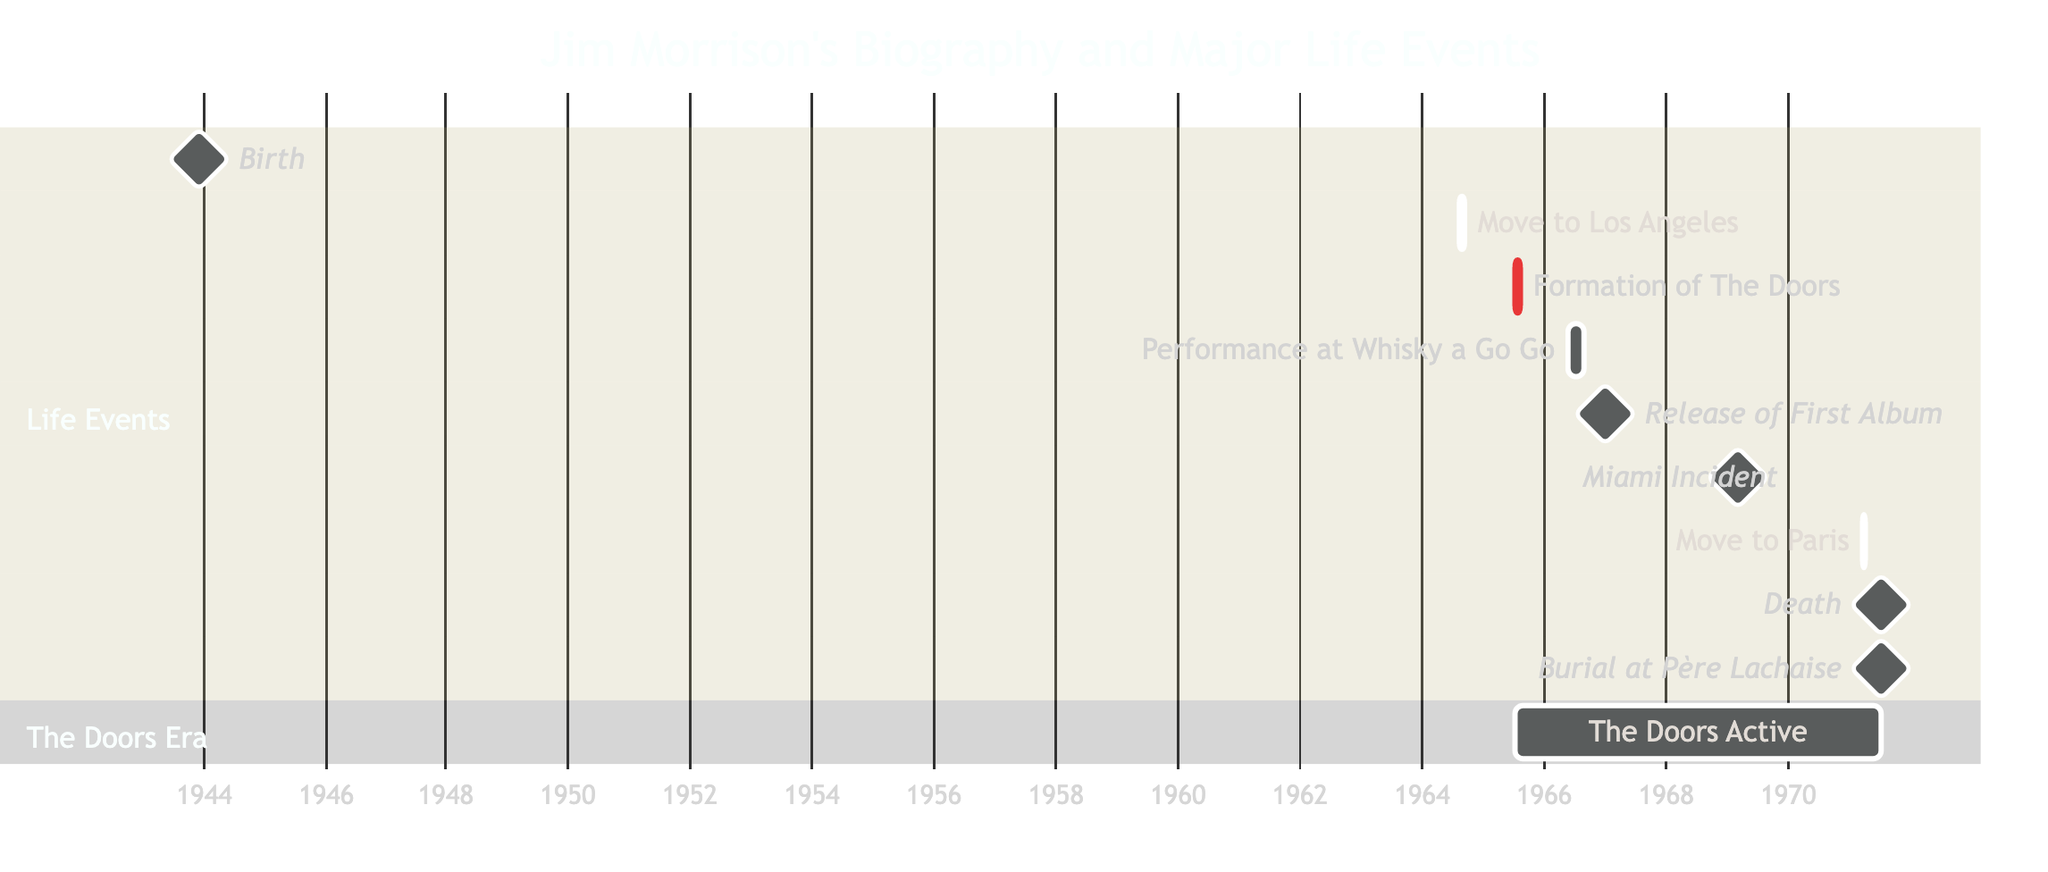What event marks Jim Morrison's birth? According to the diagram, the milestone labeled "Birth" signifies the event of Jim Morrison's birth, which occurs on December 8, 1943.
Answer: Birth When did Jim Morrison move to Los Angeles? The diagram indicates that the task "Move to Los Angeles" has a start date of August 1, 1964, and an end date of August 30, 1964.
Answer: August 1, 1964 What was the first major event in Jim Morrison's life depicted in the diagram? The first major event in the timeline is the "Birth" milestone on December 8, 1943.
Answer: Birth How long did The Doors perform at the Whisky a Go Go? The diagram shows that the performance at the Whisky a Go Go started on May 23, 1966, and ended on August 21, 1966, which totals 91 days of performances.
Answer: 91 days What were the start and end years of The Doors' active period according to the diagram? The timeline indicates that The Doors were active from July 1, 1965, through July 3, 1971, spanning a total of 6 years.
Answer: 1965 to 1971 What significant event happened on March 1, 1969? The diagram shows a milestone labeled "Miami Incident" occurring on March 1, 1969, marking the infamous concert that led to an arrest.
Answer: Miami Incident How many milestones are shown in the diagram? By counting the milestones labeled in the diagram, there are a total of five milestones marked with specific events in Jim Morrison's life.
Answer: 5 Which event is depicted right before Jim Morrison's death? The diagram indicates that Jim Morrison's "Move to Paris" event starts on March 11, 1971, and occurs right before his death on July 3, 1971.
Answer: Move to Paris What task is shown to have the longest duration in the diagram? By comparing the durations of the tasks, the performance at the Whisky a Go Go has the longest duration of 91 days.
Answer: Performance at Whisky a Go Go 